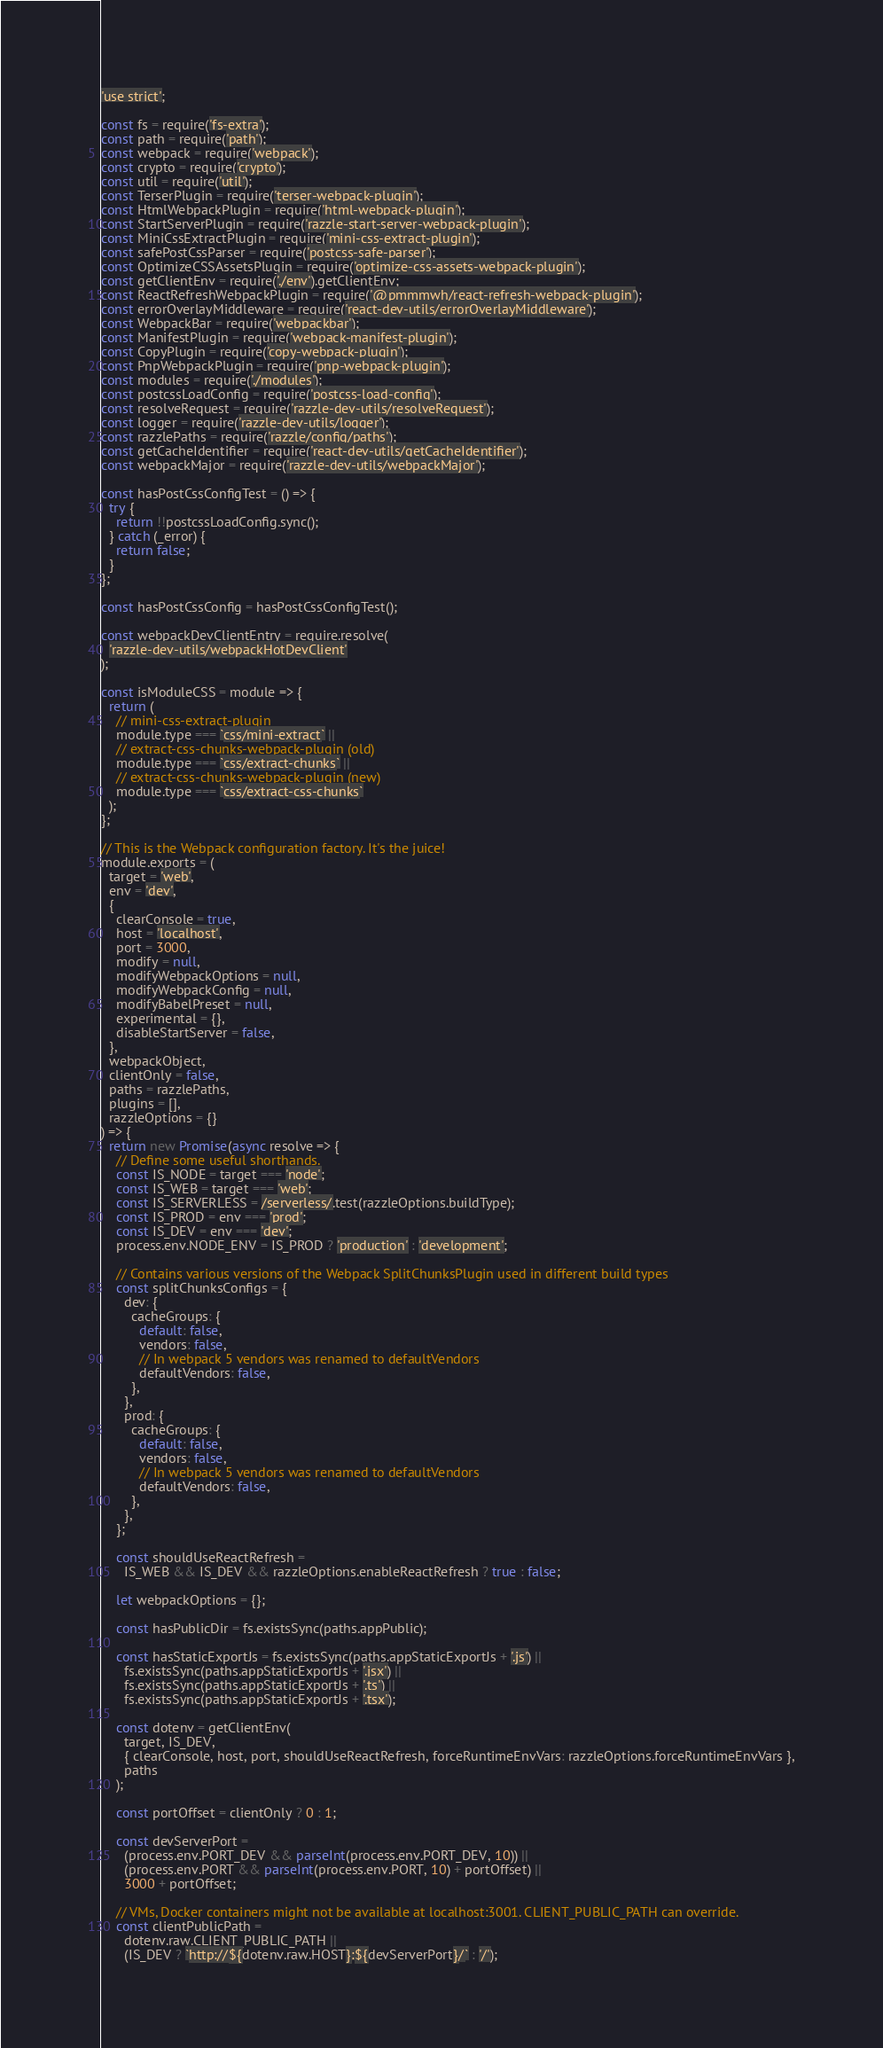Convert code to text. <code><loc_0><loc_0><loc_500><loc_500><_JavaScript_>'use strict';

const fs = require('fs-extra');
const path = require('path');
const webpack = require('webpack');
const crypto = require('crypto');
const util = require('util');
const TerserPlugin = require('terser-webpack-plugin');
const HtmlWebpackPlugin = require('html-webpack-plugin');
const StartServerPlugin = require('razzle-start-server-webpack-plugin');
const MiniCssExtractPlugin = require('mini-css-extract-plugin');
const safePostCssParser = require('postcss-safe-parser');
const OptimizeCSSAssetsPlugin = require('optimize-css-assets-webpack-plugin');
const getClientEnv = require('./env').getClientEnv;
const ReactRefreshWebpackPlugin = require('@pmmmwh/react-refresh-webpack-plugin');
const errorOverlayMiddleware = require('react-dev-utils/errorOverlayMiddleware');
const WebpackBar = require('webpackbar');
const ManifestPlugin = require('webpack-manifest-plugin');
const CopyPlugin = require('copy-webpack-plugin');
const PnpWebpackPlugin = require('pnp-webpack-plugin');
const modules = require('./modules');
const postcssLoadConfig = require('postcss-load-config');
const resolveRequest = require('razzle-dev-utils/resolveRequest');
const logger = require('razzle-dev-utils/logger');
const razzlePaths = require('razzle/config/paths');
const getCacheIdentifier = require('react-dev-utils/getCacheIdentifier');
const webpackMajor = require('razzle-dev-utils/webpackMajor');

const hasPostCssConfigTest = () => {
  try {
    return !!postcssLoadConfig.sync();
  } catch (_error) {
    return false;
  }
};

const hasPostCssConfig = hasPostCssConfigTest();

const webpackDevClientEntry = require.resolve(
  'razzle-dev-utils/webpackHotDevClient'
);

const isModuleCSS = module => {
  return (
    // mini-css-extract-plugin
    module.type === `css/mini-extract` ||
    // extract-css-chunks-webpack-plugin (old)
    module.type === `css/extract-chunks` ||
    // extract-css-chunks-webpack-plugin (new)
    module.type === `css/extract-css-chunks`
  );
};

// This is the Webpack configuration factory. It's the juice!
module.exports = (
  target = 'web',
  env = 'dev',
  {
    clearConsole = true,
    host = 'localhost',
    port = 3000,
    modify = null,
    modifyWebpackOptions = null,
    modifyWebpackConfig = null,
    modifyBabelPreset = null,
    experimental = {},
    disableStartServer = false,
  },
  webpackObject,
  clientOnly = false,
  paths = razzlePaths,
  plugins = [],
  razzleOptions = {}
) => {
  return new Promise(async resolve => {
    // Define some useful shorthands.
    const IS_NODE = target === 'node';
    const IS_WEB = target === 'web';
    const IS_SERVERLESS = /serverless/.test(razzleOptions.buildType);
    const IS_PROD = env === 'prod';
    const IS_DEV = env === 'dev';
    process.env.NODE_ENV = IS_PROD ? 'production' : 'development';

    // Contains various versions of the Webpack SplitChunksPlugin used in different build types
    const splitChunksConfigs = {
      dev: {
        cacheGroups: {
          default: false,
          vendors: false,
          // In webpack 5 vendors was renamed to defaultVendors
          defaultVendors: false,
        },
      },
      prod: {
        cacheGroups: {
          default: false,
          vendors: false,
          // In webpack 5 vendors was renamed to defaultVendors
          defaultVendors: false,
        },
      },
    };

    const shouldUseReactRefresh =
      IS_WEB && IS_DEV && razzleOptions.enableReactRefresh ? true : false;

    let webpackOptions = {};

    const hasPublicDir = fs.existsSync(paths.appPublic);

    const hasStaticExportJs = fs.existsSync(paths.appStaticExportJs + '.js') ||
      fs.existsSync(paths.appStaticExportJs + '.jsx') ||
      fs.existsSync(paths.appStaticExportJs + '.ts') ||
      fs.existsSync(paths.appStaticExportJs + '.tsx');

    const dotenv = getClientEnv(
      target, IS_DEV,
      { clearConsole, host, port, shouldUseReactRefresh, forceRuntimeEnvVars: razzleOptions.forceRuntimeEnvVars },
      paths
    );

    const portOffset = clientOnly ? 0 : 1;

    const devServerPort =
      (process.env.PORT_DEV && parseInt(process.env.PORT_DEV, 10)) ||
      (process.env.PORT && parseInt(process.env.PORT, 10) + portOffset) ||
      3000 + portOffset;

    // VMs, Docker containers might not be available at localhost:3001. CLIENT_PUBLIC_PATH can override.
    const clientPublicPath =
      dotenv.raw.CLIENT_PUBLIC_PATH ||
      (IS_DEV ? `http://${dotenv.raw.HOST}:${devServerPort}/` : '/');
</code> 